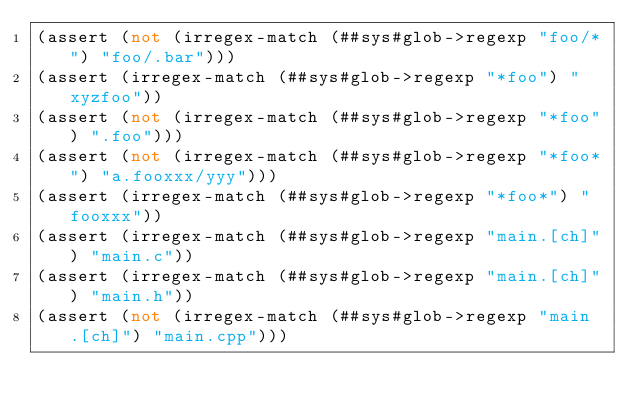Convert code to text. <code><loc_0><loc_0><loc_500><loc_500><_Scheme_>(assert (not (irregex-match (##sys#glob->regexp "foo/*") "foo/.bar")))
(assert (irregex-match (##sys#glob->regexp "*foo") "xyzfoo"))
(assert (not (irregex-match (##sys#glob->regexp "*foo") ".foo")))
(assert (not (irregex-match (##sys#glob->regexp "*foo*") "a.fooxxx/yyy")))
(assert (irregex-match (##sys#glob->regexp "*foo*") "fooxxx"))
(assert (irregex-match (##sys#glob->regexp "main.[ch]") "main.c"))
(assert (irregex-match (##sys#glob->regexp "main.[ch]") "main.h"))
(assert (not (irregex-match (##sys#glob->regexp "main.[ch]") "main.cpp")))</code> 